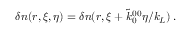Convert formula to latex. <formula><loc_0><loc_0><loc_500><loc_500>\begin{array} { r } { \delta n ( r , \xi , \eta ) = \delta n ( r , \xi + \tilde { k } _ { 0 } ^ { 0 0 } \eta / k _ { L } ) \, . } \end{array}</formula> 